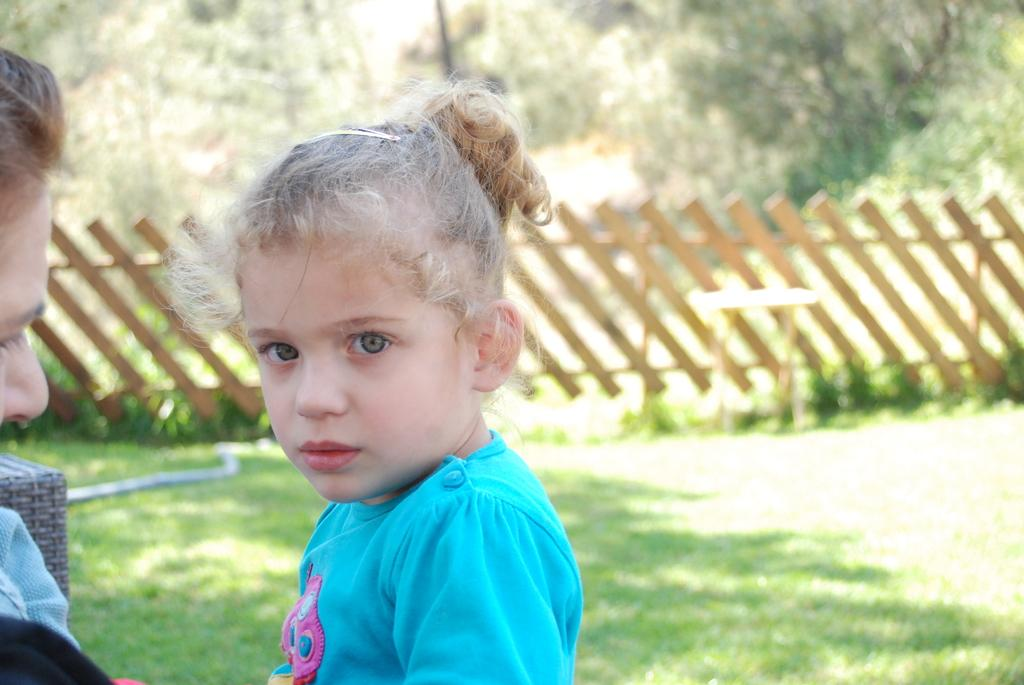How many people are in the image? There are two persons in the image. Can you describe one of the persons? One of the persons is a girl. What is the girl wearing? The girl is wearing a blue shirt. What can be seen in the background of the image? There is a table, a wooden fence, a group of trees, and the sky visible in the background of the image. What type of error can be seen on the girl's shirt in the image? There is no error visible on the girl's shirt in the image; it is a blue shirt without any visible errors. What scent is associated with the wooden fence in the image? There is no mention of a scent in the image, and the wooden fence is not associated with any particular scent. 